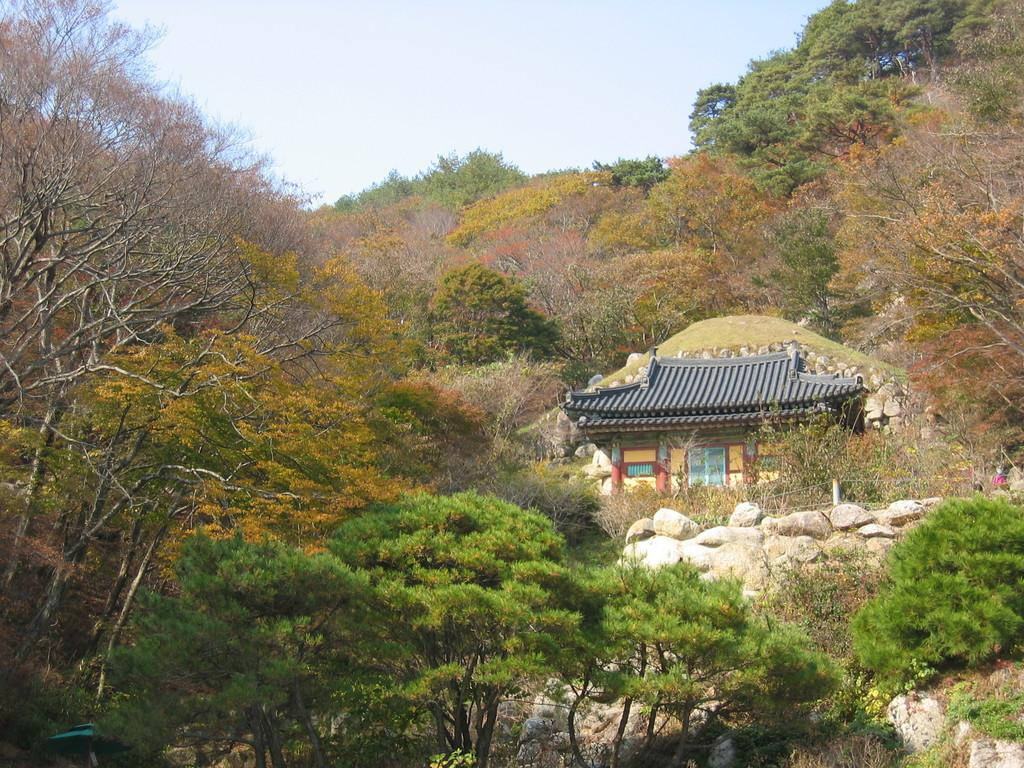What type of vegetation can be seen in the image? There are trees in the image. What type of structure is present in the image? There is a house in the image. What features can be seen on the house? The house has windows and doors. What type of barrier is visible in the image? There is fencing in the image. What type of material is present on the ground in the image? There are stones in the image. What is the color of the sky in the image? The sky is blue and white in color. Can you tell me how many waves are crashing against the house in the image? There are no waves present in the image; it features a house with trees, fencing, and stones. What type of tool is being used to cut the scissors in the image? There are no scissors or cutting tools present in the image. 